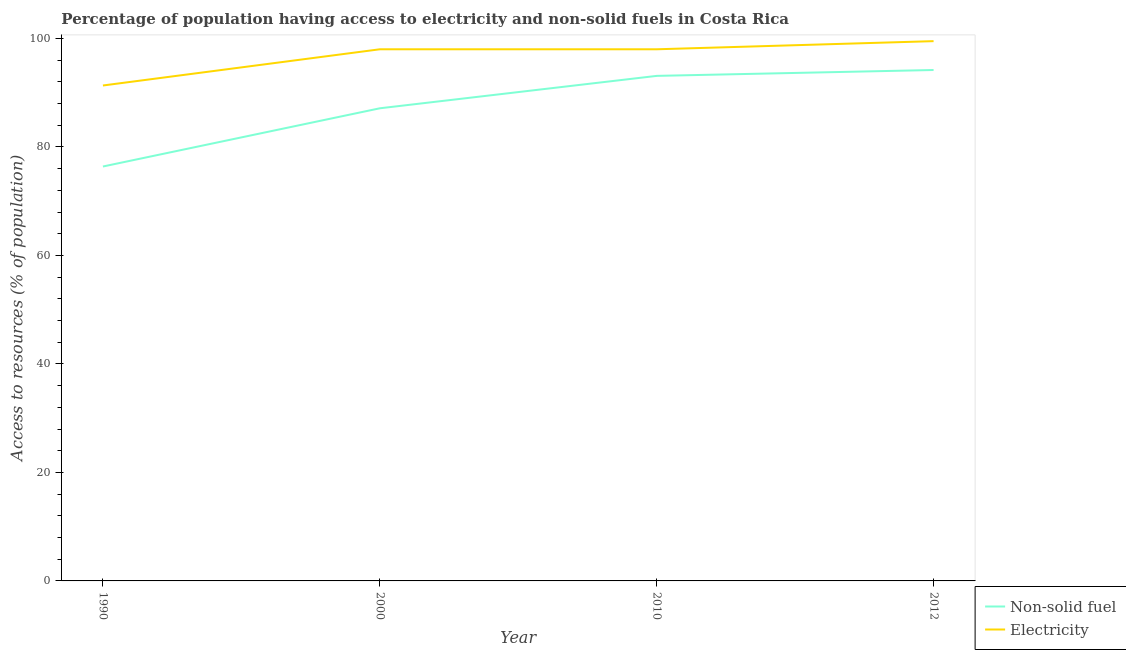How many different coloured lines are there?
Your answer should be very brief. 2. Does the line corresponding to percentage of population having access to electricity intersect with the line corresponding to percentage of population having access to non-solid fuel?
Give a very brief answer. No. What is the percentage of population having access to non-solid fuel in 2010?
Your response must be concise. 93.1. Across all years, what is the maximum percentage of population having access to electricity?
Offer a terse response. 99.5. Across all years, what is the minimum percentage of population having access to non-solid fuel?
Give a very brief answer. 76.39. What is the total percentage of population having access to electricity in the graph?
Offer a very short reply. 386.83. What is the difference between the percentage of population having access to non-solid fuel in 1990 and that in 2000?
Provide a short and direct response. -10.73. What is the difference between the percentage of population having access to non-solid fuel in 2010 and the percentage of population having access to electricity in 2000?
Your answer should be compact. -4.9. What is the average percentage of population having access to non-solid fuel per year?
Your response must be concise. 87.7. In the year 1990, what is the difference between the percentage of population having access to electricity and percentage of population having access to non-solid fuel?
Offer a terse response. 14.94. In how many years, is the percentage of population having access to electricity greater than 80 %?
Ensure brevity in your answer.  4. What is the ratio of the percentage of population having access to electricity in 1990 to that in 2010?
Make the answer very short. 0.93. What is the difference between the highest and the second highest percentage of population having access to non-solid fuel?
Give a very brief answer. 1.08. What is the difference between the highest and the lowest percentage of population having access to non-solid fuel?
Provide a short and direct response. 17.79. In how many years, is the percentage of population having access to electricity greater than the average percentage of population having access to electricity taken over all years?
Provide a short and direct response. 3. Is the sum of the percentage of population having access to non-solid fuel in 1990 and 2012 greater than the maximum percentage of population having access to electricity across all years?
Provide a short and direct response. Yes. Does the percentage of population having access to electricity monotonically increase over the years?
Ensure brevity in your answer.  No. How many lines are there?
Your answer should be very brief. 2. What is the difference between two consecutive major ticks on the Y-axis?
Provide a short and direct response. 20. Does the graph contain any zero values?
Provide a succinct answer. No. How many legend labels are there?
Make the answer very short. 2. How are the legend labels stacked?
Ensure brevity in your answer.  Vertical. What is the title of the graph?
Your answer should be compact. Percentage of population having access to electricity and non-solid fuels in Costa Rica. Does "Exports" appear as one of the legend labels in the graph?
Make the answer very short. No. What is the label or title of the X-axis?
Your answer should be very brief. Year. What is the label or title of the Y-axis?
Offer a terse response. Access to resources (% of population). What is the Access to resources (% of population) in Non-solid fuel in 1990?
Provide a succinct answer. 76.39. What is the Access to resources (% of population) of Electricity in 1990?
Offer a terse response. 91.33. What is the Access to resources (% of population) of Non-solid fuel in 2000?
Make the answer very short. 87.12. What is the Access to resources (% of population) in Non-solid fuel in 2010?
Make the answer very short. 93.1. What is the Access to resources (% of population) in Electricity in 2010?
Your response must be concise. 98. What is the Access to resources (% of population) of Non-solid fuel in 2012?
Your answer should be very brief. 94.18. What is the Access to resources (% of population) of Electricity in 2012?
Your response must be concise. 99.5. Across all years, what is the maximum Access to resources (% of population) in Non-solid fuel?
Provide a short and direct response. 94.18. Across all years, what is the maximum Access to resources (% of population) in Electricity?
Keep it short and to the point. 99.5. Across all years, what is the minimum Access to resources (% of population) of Non-solid fuel?
Your answer should be very brief. 76.39. Across all years, what is the minimum Access to resources (% of population) in Electricity?
Give a very brief answer. 91.33. What is the total Access to resources (% of population) of Non-solid fuel in the graph?
Give a very brief answer. 350.79. What is the total Access to resources (% of population) in Electricity in the graph?
Ensure brevity in your answer.  386.83. What is the difference between the Access to resources (% of population) of Non-solid fuel in 1990 and that in 2000?
Offer a terse response. -10.73. What is the difference between the Access to resources (% of population) of Electricity in 1990 and that in 2000?
Your answer should be compact. -6.67. What is the difference between the Access to resources (% of population) in Non-solid fuel in 1990 and that in 2010?
Your answer should be very brief. -16.71. What is the difference between the Access to resources (% of population) in Electricity in 1990 and that in 2010?
Offer a very short reply. -6.67. What is the difference between the Access to resources (% of population) in Non-solid fuel in 1990 and that in 2012?
Give a very brief answer. -17.79. What is the difference between the Access to resources (% of population) of Electricity in 1990 and that in 2012?
Offer a terse response. -8.17. What is the difference between the Access to resources (% of population) of Non-solid fuel in 2000 and that in 2010?
Your response must be concise. -5.98. What is the difference between the Access to resources (% of population) of Electricity in 2000 and that in 2010?
Keep it short and to the point. 0. What is the difference between the Access to resources (% of population) of Non-solid fuel in 2000 and that in 2012?
Provide a succinct answer. -7.06. What is the difference between the Access to resources (% of population) in Non-solid fuel in 2010 and that in 2012?
Offer a very short reply. -1.08. What is the difference between the Access to resources (% of population) of Non-solid fuel in 1990 and the Access to resources (% of population) of Electricity in 2000?
Provide a succinct answer. -21.61. What is the difference between the Access to resources (% of population) of Non-solid fuel in 1990 and the Access to resources (% of population) of Electricity in 2010?
Your answer should be compact. -21.61. What is the difference between the Access to resources (% of population) in Non-solid fuel in 1990 and the Access to resources (% of population) in Electricity in 2012?
Provide a short and direct response. -23.11. What is the difference between the Access to resources (% of population) in Non-solid fuel in 2000 and the Access to resources (% of population) in Electricity in 2010?
Your answer should be very brief. -10.88. What is the difference between the Access to resources (% of population) of Non-solid fuel in 2000 and the Access to resources (% of population) of Electricity in 2012?
Ensure brevity in your answer.  -12.38. What is the difference between the Access to resources (% of population) of Non-solid fuel in 2010 and the Access to resources (% of population) of Electricity in 2012?
Give a very brief answer. -6.4. What is the average Access to resources (% of population) of Non-solid fuel per year?
Offer a terse response. 87.7. What is the average Access to resources (% of population) of Electricity per year?
Your answer should be very brief. 96.71. In the year 1990, what is the difference between the Access to resources (% of population) in Non-solid fuel and Access to resources (% of population) in Electricity?
Give a very brief answer. -14.94. In the year 2000, what is the difference between the Access to resources (% of population) of Non-solid fuel and Access to resources (% of population) of Electricity?
Give a very brief answer. -10.88. In the year 2010, what is the difference between the Access to resources (% of population) of Non-solid fuel and Access to resources (% of population) of Electricity?
Provide a succinct answer. -4.9. In the year 2012, what is the difference between the Access to resources (% of population) of Non-solid fuel and Access to resources (% of population) of Electricity?
Your answer should be very brief. -5.32. What is the ratio of the Access to resources (% of population) of Non-solid fuel in 1990 to that in 2000?
Ensure brevity in your answer.  0.88. What is the ratio of the Access to resources (% of population) of Electricity in 1990 to that in 2000?
Provide a succinct answer. 0.93. What is the ratio of the Access to resources (% of population) in Non-solid fuel in 1990 to that in 2010?
Keep it short and to the point. 0.82. What is the ratio of the Access to resources (% of population) of Electricity in 1990 to that in 2010?
Give a very brief answer. 0.93. What is the ratio of the Access to resources (% of population) in Non-solid fuel in 1990 to that in 2012?
Offer a very short reply. 0.81. What is the ratio of the Access to resources (% of population) of Electricity in 1990 to that in 2012?
Ensure brevity in your answer.  0.92. What is the ratio of the Access to resources (% of population) in Non-solid fuel in 2000 to that in 2010?
Ensure brevity in your answer.  0.94. What is the ratio of the Access to resources (% of population) of Non-solid fuel in 2000 to that in 2012?
Provide a short and direct response. 0.93. What is the ratio of the Access to resources (% of population) in Electricity in 2000 to that in 2012?
Provide a short and direct response. 0.98. What is the ratio of the Access to resources (% of population) of Non-solid fuel in 2010 to that in 2012?
Ensure brevity in your answer.  0.99. What is the ratio of the Access to resources (% of population) in Electricity in 2010 to that in 2012?
Your response must be concise. 0.98. What is the difference between the highest and the second highest Access to resources (% of population) in Non-solid fuel?
Your answer should be very brief. 1.08. What is the difference between the highest and the second highest Access to resources (% of population) in Electricity?
Provide a succinct answer. 1.5. What is the difference between the highest and the lowest Access to resources (% of population) in Non-solid fuel?
Offer a very short reply. 17.79. What is the difference between the highest and the lowest Access to resources (% of population) of Electricity?
Keep it short and to the point. 8.17. 